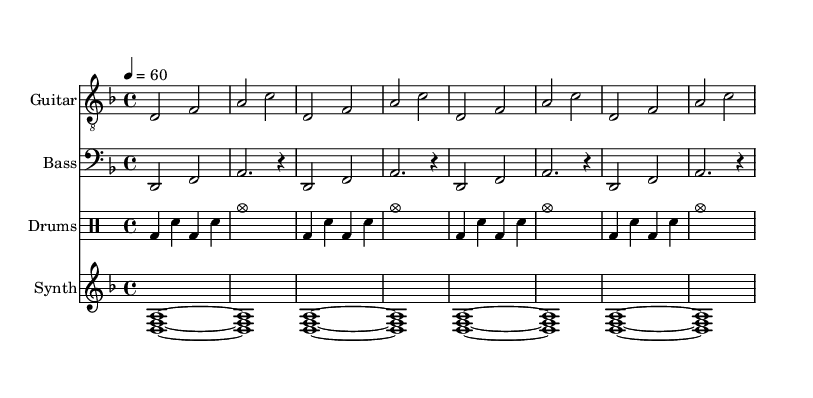What is the key signature of this music? The key signature is D minor, which contains one flat (B flat). We identify the key signature by counting the sharps or flats indicated at the beginning of the staff.
Answer: D minor What is the time signature? The time signature is 4/4, meaning there are four beats in each measure and the quarter note receives one beat. This is indicated near the beginning of the score.
Answer: 4/4 What is the tempo marking? The tempo marking indicates a speed of 60 beats per minute, which corresponds to the quarter note. The tempo is notated above the staff as "4 = 60".
Answer: 60 How many measures are repeated in the guitar section? The guitar section has a total of 4 measures that are repeated, as indicated by the "repeat unfold 4" instruction. This means the musical phrase is played multiple times.
Answer: 4 What instruments are featured in this score? The score features four instruments: Guitar, Bass, Drums, and Synth. Each instrument is represented by a separate staff. This can be determined by looking at the instrument names placed at the beginning of each staff.
Answer: Guitar, Bass, Drums, Synth What is the drum pattern in terms of components? The drum pattern consists of a bass drum, snare drum, and cymbals. This can be identified by looking at the drum staff, where different notations represent different drum sounds.
Answer: Bass drum, snare drum, cymbals Are there any synthesizer chords shown? Yes, the synthesizer plays a chord consisting of the notes D, F, and A repeatedly throughout the piece. This is indicated by the notation showing the combination of these notes played simultaneously.
Answer: D, F, A 